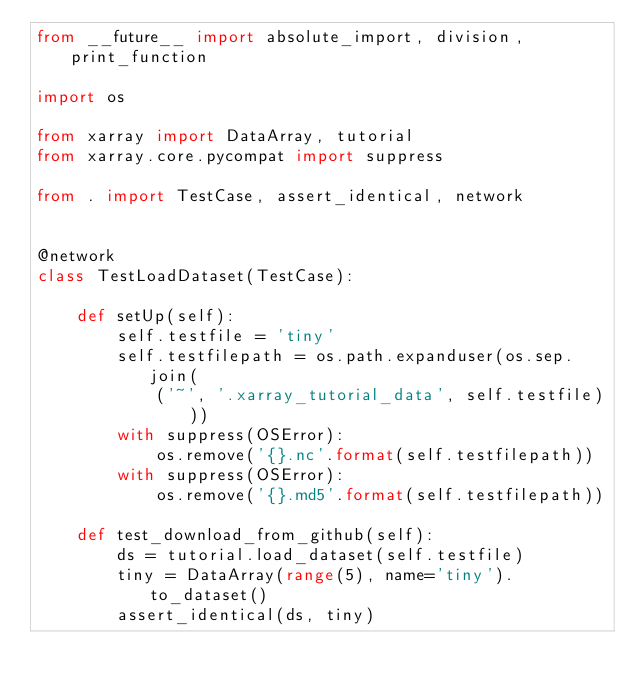<code> <loc_0><loc_0><loc_500><loc_500><_Python_>from __future__ import absolute_import, division, print_function

import os

from xarray import DataArray, tutorial
from xarray.core.pycompat import suppress

from . import TestCase, assert_identical, network


@network
class TestLoadDataset(TestCase):

    def setUp(self):
        self.testfile = 'tiny'
        self.testfilepath = os.path.expanduser(os.sep.join(
            ('~', '.xarray_tutorial_data', self.testfile)))
        with suppress(OSError):
            os.remove('{}.nc'.format(self.testfilepath))
        with suppress(OSError):
            os.remove('{}.md5'.format(self.testfilepath))

    def test_download_from_github(self):
        ds = tutorial.load_dataset(self.testfile)
        tiny = DataArray(range(5), name='tiny').to_dataset()
        assert_identical(ds, tiny)
</code> 